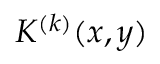Convert formula to latex. <formula><loc_0><loc_0><loc_500><loc_500>K ^ { ( k ) } ( { x } , { y } )</formula> 